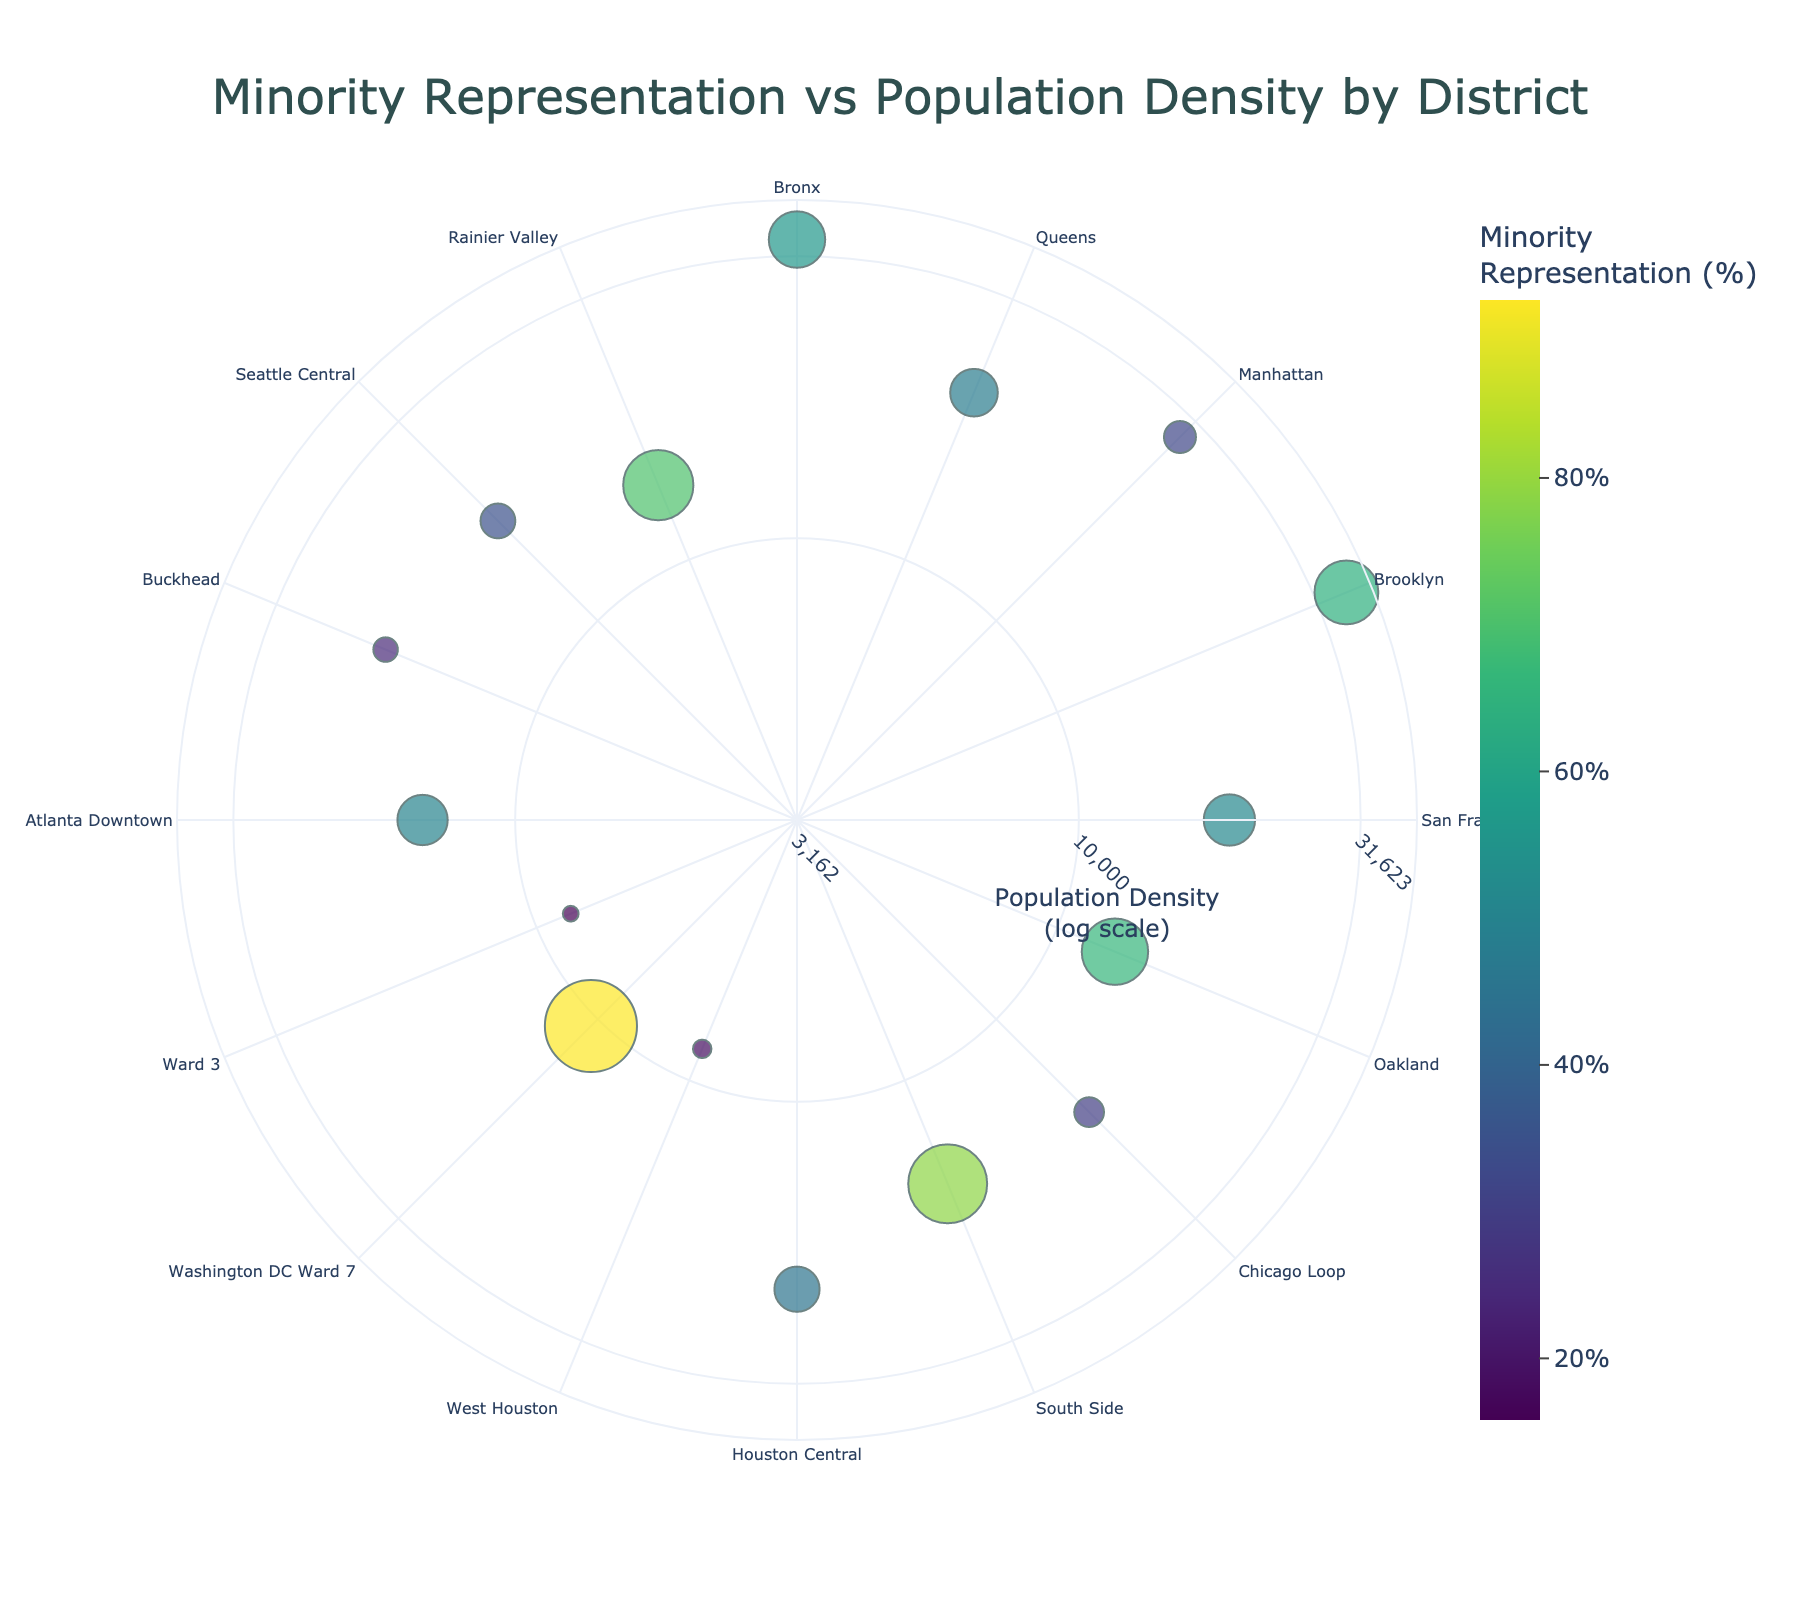what is the title of the figure? The title is displayed at the top center of the figure as 'Minority Representation vs Population Density by District'.
Answer: Minority Representation vs Population Density by District which district has the highest minority representation? By referring to the color scale and the size of the markers, it's noticeable that Washington DC Ward 7 has the highest value at 92.1%.
Answer: Washington DC Ward 7 how many districts have a population density less than 10,000? Population density is represented on a logarithmic scale. By identifying data points with radial values corresponding to less than 4 (log10 of 10,000), we find three districts (West Houston, Ward 3, and Washington DC Ward 7).
Answer: 3 which district has the lowest minority representation? By looking at the color scale and searching for the smallest marker size, Ward 3 in Washington DC has the lowest minority representation at 15.8%.
Answer: Ward 3 what is the average minority representation of districts with population density above 30,000? Only Bronx and Brooklyn have population densities above 30,000. Their minority representations are 56.4% and 63.8%, respectively. The average is calculated as (56.4 + 63.8) / 2 = 60.1%.
Answer: 60.1% how does the minority representation in Oakland compare to that in Brooklyn? Oakland's minority representation is 66.4% while Brooklyn's is 63.8%. 66.4% is greater than 63.8%.
Answer: Oakland's is greater which districts have a minority representation between 40% and 60%? By examining the marker sizes and colors, five districts fall into this range: Queens (47.6%), San Francisco (51.3%), Houston Central (45.2%), Atlanta Downtown (50.3%), and Seattle Central (34.8% falls short, so it's excluded).
Answer: Queens, San Francisco, Houston Central, Atlanta Downtown what's the combined minority representation of Buckhead and Chicago Loop? Buckhead has 24.5% and Chicago Loop has 29.7%. Their combined representation is 24.5 + 29.7 = 54.2.
Answer: 54.2 how does population density affect minority representation? By observing the plot, there is no clear linear relationship between population density and minority representation. Districts with high and low population densities both exhibit wide ranges of minority representation.
Answer: No clear linear relationship 